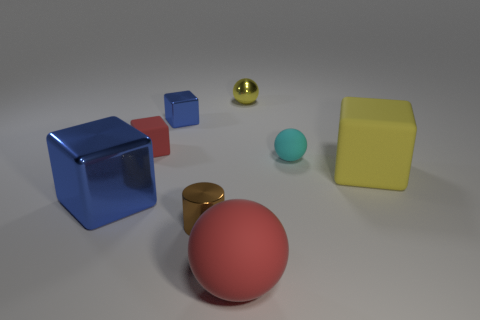Add 1 small yellow objects. How many objects exist? 9 Subtract all balls. How many objects are left? 5 Subtract 0 green spheres. How many objects are left? 8 Subtract all small cyan spheres. Subtract all rubber objects. How many objects are left? 3 Add 6 small metallic cylinders. How many small metallic cylinders are left? 7 Add 8 red blocks. How many red blocks exist? 9 